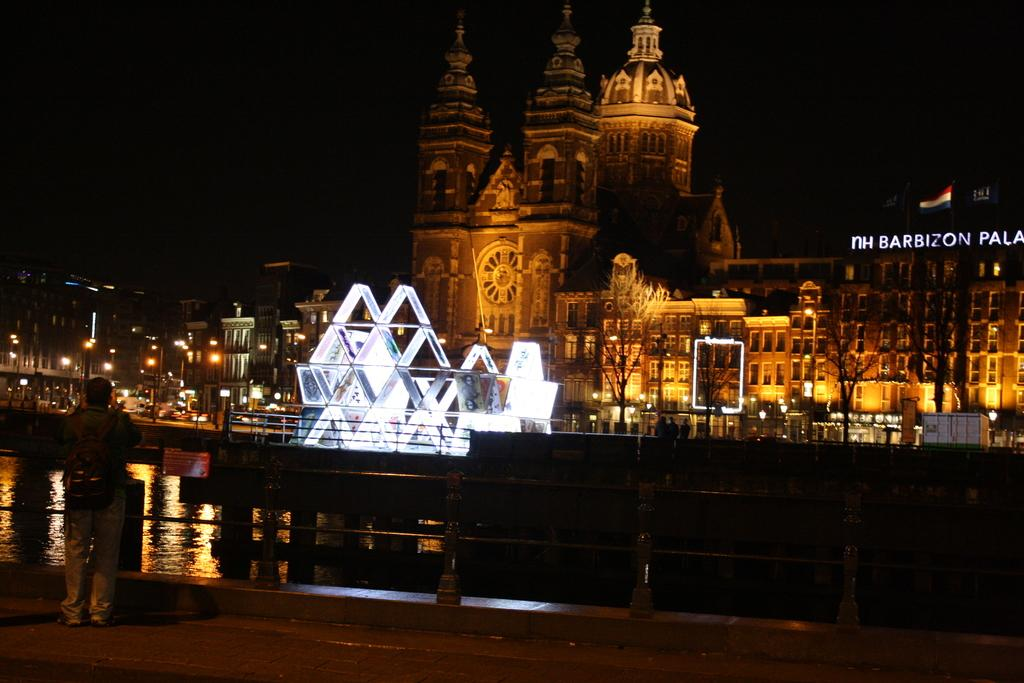What type of structures are present in the image? There are buildings with windows in the image. What can be seen illuminated in the image? There are lights visible in the image. What type of natural elements are present in the image? There are trees and water visible in the image. What type of barrier is present in the image? There is a fence in the image. What is the person in the image doing? There is a person standing on the ground in the image. How would you describe the overall lighting in the image? The background of the image is dark. What type of liquid is the person drinking in the image? There is no person drinking any liquid in the image; the person is standing on the ground. What type of fiction is the person reading in the image? There is no person reading any fiction in the image; the person is standing on the ground. 